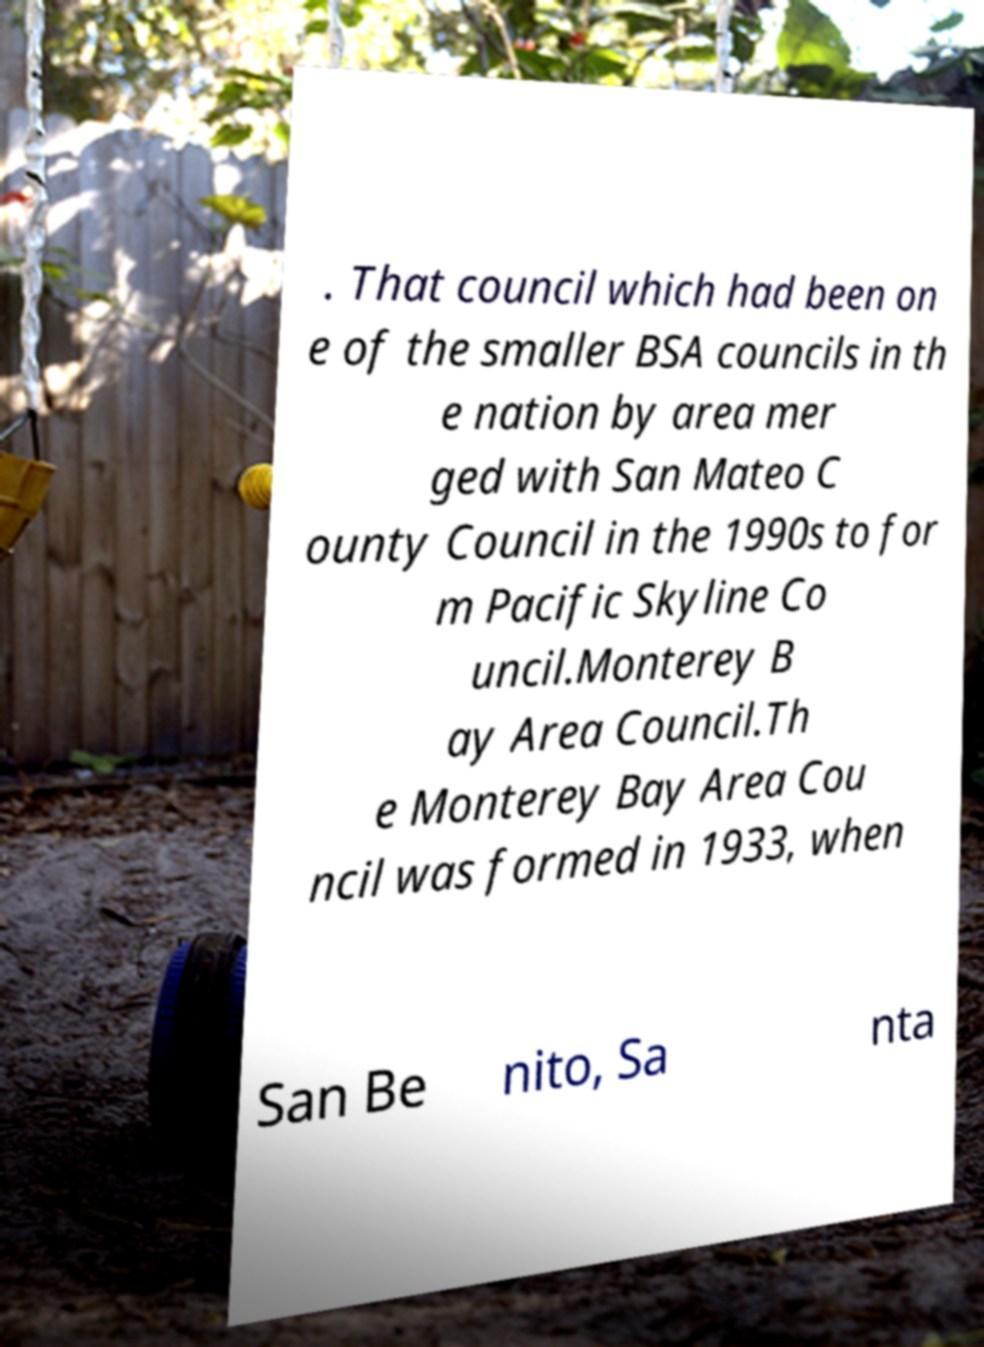Please read and relay the text visible in this image. What does it say? . That council which had been on e of the smaller BSA councils in th e nation by area mer ged with San Mateo C ounty Council in the 1990s to for m Pacific Skyline Co uncil.Monterey B ay Area Council.Th e Monterey Bay Area Cou ncil was formed in 1933, when San Be nito, Sa nta 